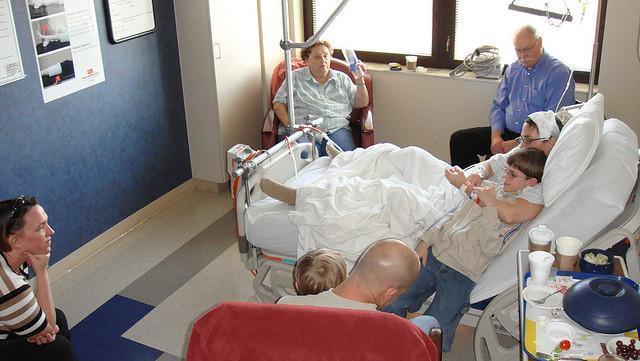How many people are in the picture?
Give a very brief answer. 7. How many chairs are visible?
Give a very brief answer. 2. How many people are there?
Give a very brief answer. 6. 